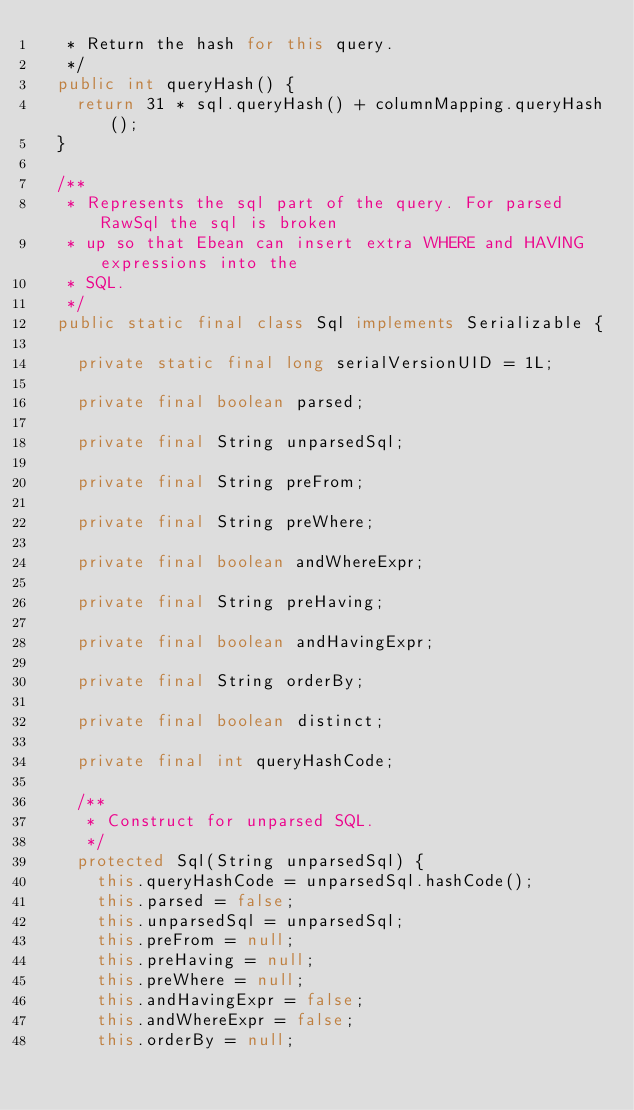Convert code to text. <code><loc_0><loc_0><loc_500><loc_500><_Java_>   * Return the hash for this query.
   */
  public int queryHash() {
    return 31 * sql.queryHash() + columnMapping.queryHash();
  }

  /**
   * Represents the sql part of the query. For parsed RawSql the sql is broken
   * up so that Ebean can insert extra WHERE and HAVING expressions into the
   * SQL.
   */
  public static final class Sql implements Serializable {

    private static final long serialVersionUID = 1L;

    private final boolean parsed;

    private final String unparsedSql;

    private final String preFrom;

    private final String preWhere;

    private final boolean andWhereExpr;

    private final String preHaving;

    private final boolean andHavingExpr;

    private final String orderBy;

    private final boolean distinct;

    private final int queryHashCode;

    /**
     * Construct for unparsed SQL.
     */
    protected Sql(String unparsedSql) {
      this.queryHashCode = unparsedSql.hashCode();
      this.parsed = false;
      this.unparsedSql = unparsedSql;
      this.preFrom = null;
      this.preHaving = null;
      this.preWhere = null;
      this.andHavingExpr = false;
      this.andWhereExpr = false;
      this.orderBy = null;</code> 